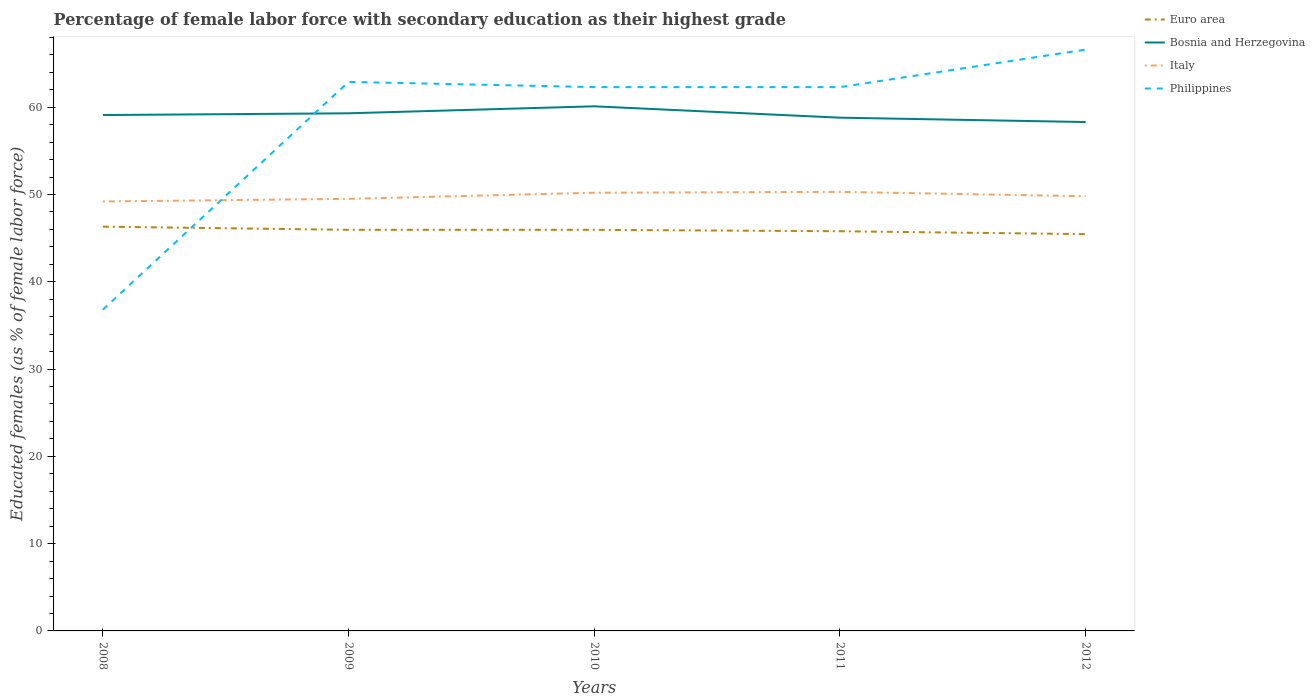How many different coloured lines are there?
Keep it short and to the point. 4. Across all years, what is the maximum percentage of female labor force with secondary education in Italy?
Provide a short and direct response. 49.2. What is the difference between the highest and the second highest percentage of female labor force with secondary education in Bosnia and Herzegovina?
Offer a terse response. 1.8. Is the percentage of female labor force with secondary education in Italy strictly greater than the percentage of female labor force with secondary education in Euro area over the years?
Provide a succinct answer. No. How many lines are there?
Your response must be concise. 4. Are the values on the major ticks of Y-axis written in scientific E-notation?
Provide a short and direct response. No. Does the graph contain any zero values?
Give a very brief answer. No. Where does the legend appear in the graph?
Provide a succinct answer. Top right. What is the title of the graph?
Give a very brief answer. Percentage of female labor force with secondary education as their highest grade. What is the label or title of the Y-axis?
Your answer should be compact. Educated females (as % of female labor force). What is the Educated females (as % of female labor force) in Euro area in 2008?
Your answer should be very brief. 46.31. What is the Educated females (as % of female labor force) in Bosnia and Herzegovina in 2008?
Make the answer very short. 59.1. What is the Educated females (as % of female labor force) of Italy in 2008?
Provide a short and direct response. 49.2. What is the Educated females (as % of female labor force) in Philippines in 2008?
Provide a short and direct response. 36.8. What is the Educated females (as % of female labor force) of Euro area in 2009?
Provide a succinct answer. 45.95. What is the Educated females (as % of female labor force) of Bosnia and Herzegovina in 2009?
Offer a very short reply. 59.3. What is the Educated females (as % of female labor force) of Italy in 2009?
Provide a short and direct response. 49.5. What is the Educated females (as % of female labor force) in Philippines in 2009?
Offer a very short reply. 62.9. What is the Educated females (as % of female labor force) of Euro area in 2010?
Your answer should be compact. 45.95. What is the Educated females (as % of female labor force) in Bosnia and Herzegovina in 2010?
Offer a very short reply. 60.1. What is the Educated females (as % of female labor force) of Italy in 2010?
Ensure brevity in your answer.  50.2. What is the Educated females (as % of female labor force) in Philippines in 2010?
Your answer should be compact. 62.3. What is the Educated females (as % of female labor force) of Euro area in 2011?
Give a very brief answer. 45.79. What is the Educated females (as % of female labor force) of Bosnia and Herzegovina in 2011?
Ensure brevity in your answer.  58.8. What is the Educated females (as % of female labor force) in Italy in 2011?
Your answer should be compact. 50.3. What is the Educated females (as % of female labor force) of Philippines in 2011?
Provide a succinct answer. 62.3. What is the Educated females (as % of female labor force) in Euro area in 2012?
Keep it short and to the point. 45.46. What is the Educated females (as % of female labor force) of Bosnia and Herzegovina in 2012?
Make the answer very short. 58.3. What is the Educated females (as % of female labor force) in Italy in 2012?
Keep it short and to the point. 49.8. What is the Educated females (as % of female labor force) in Philippines in 2012?
Make the answer very short. 66.6. Across all years, what is the maximum Educated females (as % of female labor force) in Euro area?
Provide a short and direct response. 46.31. Across all years, what is the maximum Educated females (as % of female labor force) of Bosnia and Herzegovina?
Provide a short and direct response. 60.1. Across all years, what is the maximum Educated females (as % of female labor force) in Italy?
Your response must be concise. 50.3. Across all years, what is the maximum Educated females (as % of female labor force) of Philippines?
Offer a terse response. 66.6. Across all years, what is the minimum Educated females (as % of female labor force) in Euro area?
Make the answer very short. 45.46. Across all years, what is the minimum Educated females (as % of female labor force) of Bosnia and Herzegovina?
Give a very brief answer. 58.3. Across all years, what is the minimum Educated females (as % of female labor force) of Italy?
Give a very brief answer. 49.2. Across all years, what is the minimum Educated females (as % of female labor force) in Philippines?
Keep it short and to the point. 36.8. What is the total Educated females (as % of female labor force) of Euro area in the graph?
Offer a terse response. 229.46. What is the total Educated females (as % of female labor force) of Bosnia and Herzegovina in the graph?
Your response must be concise. 295.6. What is the total Educated females (as % of female labor force) in Italy in the graph?
Keep it short and to the point. 249. What is the total Educated females (as % of female labor force) in Philippines in the graph?
Keep it short and to the point. 290.9. What is the difference between the Educated females (as % of female labor force) of Euro area in 2008 and that in 2009?
Ensure brevity in your answer.  0.36. What is the difference between the Educated females (as % of female labor force) of Italy in 2008 and that in 2009?
Make the answer very short. -0.3. What is the difference between the Educated females (as % of female labor force) of Philippines in 2008 and that in 2009?
Your answer should be compact. -26.1. What is the difference between the Educated females (as % of female labor force) of Euro area in 2008 and that in 2010?
Your answer should be compact. 0.36. What is the difference between the Educated females (as % of female labor force) of Philippines in 2008 and that in 2010?
Your answer should be very brief. -25.5. What is the difference between the Educated females (as % of female labor force) of Euro area in 2008 and that in 2011?
Make the answer very short. 0.52. What is the difference between the Educated females (as % of female labor force) in Italy in 2008 and that in 2011?
Give a very brief answer. -1.1. What is the difference between the Educated females (as % of female labor force) of Philippines in 2008 and that in 2011?
Give a very brief answer. -25.5. What is the difference between the Educated females (as % of female labor force) in Euro area in 2008 and that in 2012?
Your response must be concise. 0.86. What is the difference between the Educated females (as % of female labor force) of Philippines in 2008 and that in 2012?
Keep it short and to the point. -29.8. What is the difference between the Educated females (as % of female labor force) of Euro area in 2009 and that in 2010?
Your answer should be compact. 0. What is the difference between the Educated females (as % of female labor force) in Philippines in 2009 and that in 2010?
Give a very brief answer. 0.6. What is the difference between the Educated females (as % of female labor force) in Euro area in 2009 and that in 2011?
Offer a terse response. 0.16. What is the difference between the Educated females (as % of female labor force) of Bosnia and Herzegovina in 2009 and that in 2011?
Provide a short and direct response. 0.5. What is the difference between the Educated females (as % of female labor force) in Italy in 2009 and that in 2011?
Provide a short and direct response. -0.8. What is the difference between the Educated females (as % of female labor force) in Philippines in 2009 and that in 2011?
Provide a succinct answer. 0.6. What is the difference between the Educated females (as % of female labor force) of Euro area in 2009 and that in 2012?
Make the answer very short. 0.5. What is the difference between the Educated females (as % of female labor force) in Italy in 2009 and that in 2012?
Ensure brevity in your answer.  -0.3. What is the difference between the Educated females (as % of female labor force) of Philippines in 2009 and that in 2012?
Your response must be concise. -3.7. What is the difference between the Educated females (as % of female labor force) in Euro area in 2010 and that in 2011?
Your response must be concise. 0.16. What is the difference between the Educated females (as % of female labor force) of Bosnia and Herzegovina in 2010 and that in 2011?
Your response must be concise. 1.3. What is the difference between the Educated females (as % of female labor force) of Italy in 2010 and that in 2011?
Your answer should be very brief. -0.1. What is the difference between the Educated females (as % of female labor force) in Euro area in 2010 and that in 2012?
Your answer should be compact. 0.49. What is the difference between the Educated females (as % of female labor force) of Italy in 2010 and that in 2012?
Provide a succinct answer. 0.4. What is the difference between the Educated females (as % of female labor force) of Philippines in 2010 and that in 2012?
Offer a very short reply. -4.3. What is the difference between the Educated females (as % of female labor force) in Euro area in 2011 and that in 2012?
Your response must be concise. 0.33. What is the difference between the Educated females (as % of female labor force) in Euro area in 2008 and the Educated females (as % of female labor force) in Bosnia and Herzegovina in 2009?
Your response must be concise. -12.99. What is the difference between the Educated females (as % of female labor force) in Euro area in 2008 and the Educated females (as % of female labor force) in Italy in 2009?
Your response must be concise. -3.19. What is the difference between the Educated females (as % of female labor force) in Euro area in 2008 and the Educated females (as % of female labor force) in Philippines in 2009?
Your answer should be very brief. -16.59. What is the difference between the Educated females (as % of female labor force) in Bosnia and Herzegovina in 2008 and the Educated females (as % of female labor force) in Italy in 2009?
Your answer should be compact. 9.6. What is the difference between the Educated females (as % of female labor force) in Bosnia and Herzegovina in 2008 and the Educated females (as % of female labor force) in Philippines in 2009?
Your response must be concise. -3.8. What is the difference between the Educated females (as % of female labor force) of Italy in 2008 and the Educated females (as % of female labor force) of Philippines in 2009?
Provide a short and direct response. -13.7. What is the difference between the Educated females (as % of female labor force) of Euro area in 2008 and the Educated females (as % of female labor force) of Bosnia and Herzegovina in 2010?
Ensure brevity in your answer.  -13.79. What is the difference between the Educated females (as % of female labor force) of Euro area in 2008 and the Educated females (as % of female labor force) of Italy in 2010?
Keep it short and to the point. -3.89. What is the difference between the Educated females (as % of female labor force) of Euro area in 2008 and the Educated females (as % of female labor force) of Philippines in 2010?
Your answer should be compact. -15.99. What is the difference between the Educated females (as % of female labor force) in Bosnia and Herzegovina in 2008 and the Educated females (as % of female labor force) in Italy in 2010?
Keep it short and to the point. 8.9. What is the difference between the Educated females (as % of female labor force) of Euro area in 2008 and the Educated females (as % of female labor force) of Bosnia and Herzegovina in 2011?
Provide a short and direct response. -12.49. What is the difference between the Educated females (as % of female labor force) in Euro area in 2008 and the Educated females (as % of female labor force) in Italy in 2011?
Make the answer very short. -3.99. What is the difference between the Educated females (as % of female labor force) of Euro area in 2008 and the Educated females (as % of female labor force) of Philippines in 2011?
Offer a very short reply. -15.99. What is the difference between the Educated females (as % of female labor force) in Bosnia and Herzegovina in 2008 and the Educated females (as % of female labor force) in Italy in 2011?
Provide a succinct answer. 8.8. What is the difference between the Educated females (as % of female labor force) of Bosnia and Herzegovina in 2008 and the Educated females (as % of female labor force) of Philippines in 2011?
Your response must be concise. -3.2. What is the difference between the Educated females (as % of female labor force) of Italy in 2008 and the Educated females (as % of female labor force) of Philippines in 2011?
Provide a succinct answer. -13.1. What is the difference between the Educated females (as % of female labor force) of Euro area in 2008 and the Educated females (as % of female labor force) of Bosnia and Herzegovina in 2012?
Provide a short and direct response. -11.99. What is the difference between the Educated females (as % of female labor force) in Euro area in 2008 and the Educated females (as % of female labor force) in Italy in 2012?
Your answer should be very brief. -3.49. What is the difference between the Educated females (as % of female labor force) in Euro area in 2008 and the Educated females (as % of female labor force) in Philippines in 2012?
Your response must be concise. -20.29. What is the difference between the Educated females (as % of female labor force) of Bosnia and Herzegovina in 2008 and the Educated females (as % of female labor force) of Italy in 2012?
Provide a short and direct response. 9.3. What is the difference between the Educated females (as % of female labor force) of Italy in 2008 and the Educated females (as % of female labor force) of Philippines in 2012?
Give a very brief answer. -17.4. What is the difference between the Educated females (as % of female labor force) of Euro area in 2009 and the Educated females (as % of female labor force) of Bosnia and Herzegovina in 2010?
Provide a short and direct response. -14.15. What is the difference between the Educated females (as % of female labor force) of Euro area in 2009 and the Educated females (as % of female labor force) of Italy in 2010?
Give a very brief answer. -4.25. What is the difference between the Educated females (as % of female labor force) in Euro area in 2009 and the Educated females (as % of female labor force) in Philippines in 2010?
Your answer should be compact. -16.35. What is the difference between the Educated females (as % of female labor force) in Bosnia and Herzegovina in 2009 and the Educated females (as % of female labor force) in Philippines in 2010?
Your response must be concise. -3. What is the difference between the Educated females (as % of female labor force) of Euro area in 2009 and the Educated females (as % of female labor force) of Bosnia and Herzegovina in 2011?
Offer a terse response. -12.85. What is the difference between the Educated females (as % of female labor force) of Euro area in 2009 and the Educated females (as % of female labor force) of Italy in 2011?
Make the answer very short. -4.35. What is the difference between the Educated females (as % of female labor force) in Euro area in 2009 and the Educated females (as % of female labor force) in Philippines in 2011?
Make the answer very short. -16.35. What is the difference between the Educated females (as % of female labor force) in Bosnia and Herzegovina in 2009 and the Educated females (as % of female labor force) in Philippines in 2011?
Make the answer very short. -3. What is the difference between the Educated females (as % of female labor force) in Euro area in 2009 and the Educated females (as % of female labor force) in Bosnia and Herzegovina in 2012?
Keep it short and to the point. -12.35. What is the difference between the Educated females (as % of female labor force) in Euro area in 2009 and the Educated females (as % of female labor force) in Italy in 2012?
Your response must be concise. -3.85. What is the difference between the Educated females (as % of female labor force) in Euro area in 2009 and the Educated females (as % of female labor force) in Philippines in 2012?
Provide a succinct answer. -20.65. What is the difference between the Educated females (as % of female labor force) in Bosnia and Herzegovina in 2009 and the Educated females (as % of female labor force) in Italy in 2012?
Offer a terse response. 9.5. What is the difference between the Educated females (as % of female labor force) of Bosnia and Herzegovina in 2009 and the Educated females (as % of female labor force) of Philippines in 2012?
Your answer should be very brief. -7.3. What is the difference between the Educated females (as % of female labor force) in Italy in 2009 and the Educated females (as % of female labor force) in Philippines in 2012?
Give a very brief answer. -17.1. What is the difference between the Educated females (as % of female labor force) in Euro area in 2010 and the Educated females (as % of female labor force) in Bosnia and Herzegovina in 2011?
Keep it short and to the point. -12.85. What is the difference between the Educated females (as % of female labor force) of Euro area in 2010 and the Educated females (as % of female labor force) of Italy in 2011?
Your answer should be very brief. -4.35. What is the difference between the Educated females (as % of female labor force) in Euro area in 2010 and the Educated females (as % of female labor force) in Philippines in 2011?
Your answer should be compact. -16.35. What is the difference between the Educated females (as % of female labor force) of Bosnia and Herzegovina in 2010 and the Educated females (as % of female labor force) of Philippines in 2011?
Keep it short and to the point. -2.2. What is the difference between the Educated females (as % of female labor force) in Italy in 2010 and the Educated females (as % of female labor force) in Philippines in 2011?
Offer a very short reply. -12.1. What is the difference between the Educated females (as % of female labor force) in Euro area in 2010 and the Educated females (as % of female labor force) in Bosnia and Herzegovina in 2012?
Give a very brief answer. -12.35. What is the difference between the Educated females (as % of female labor force) of Euro area in 2010 and the Educated females (as % of female labor force) of Italy in 2012?
Ensure brevity in your answer.  -3.85. What is the difference between the Educated females (as % of female labor force) of Euro area in 2010 and the Educated females (as % of female labor force) of Philippines in 2012?
Give a very brief answer. -20.65. What is the difference between the Educated females (as % of female labor force) in Bosnia and Herzegovina in 2010 and the Educated females (as % of female labor force) in Philippines in 2012?
Give a very brief answer. -6.5. What is the difference between the Educated females (as % of female labor force) in Italy in 2010 and the Educated females (as % of female labor force) in Philippines in 2012?
Your answer should be compact. -16.4. What is the difference between the Educated females (as % of female labor force) of Euro area in 2011 and the Educated females (as % of female labor force) of Bosnia and Herzegovina in 2012?
Your answer should be compact. -12.51. What is the difference between the Educated females (as % of female labor force) of Euro area in 2011 and the Educated females (as % of female labor force) of Italy in 2012?
Provide a short and direct response. -4.01. What is the difference between the Educated females (as % of female labor force) of Euro area in 2011 and the Educated females (as % of female labor force) of Philippines in 2012?
Keep it short and to the point. -20.81. What is the difference between the Educated females (as % of female labor force) in Bosnia and Herzegovina in 2011 and the Educated females (as % of female labor force) in Italy in 2012?
Your answer should be very brief. 9. What is the difference between the Educated females (as % of female labor force) of Italy in 2011 and the Educated females (as % of female labor force) of Philippines in 2012?
Your response must be concise. -16.3. What is the average Educated females (as % of female labor force) in Euro area per year?
Your answer should be compact. 45.89. What is the average Educated females (as % of female labor force) of Bosnia and Herzegovina per year?
Your answer should be very brief. 59.12. What is the average Educated females (as % of female labor force) of Italy per year?
Make the answer very short. 49.8. What is the average Educated females (as % of female labor force) of Philippines per year?
Provide a short and direct response. 58.18. In the year 2008, what is the difference between the Educated females (as % of female labor force) of Euro area and Educated females (as % of female labor force) of Bosnia and Herzegovina?
Ensure brevity in your answer.  -12.79. In the year 2008, what is the difference between the Educated females (as % of female labor force) of Euro area and Educated females (as % of female labor force) of Italy?
Your response must be concise. -2.89. In the year 2008, what is the difference between the Educated females (as % of female labor force) of Euro area and Educated females (as % of female labor force) of Philippines?
Your answer should be compact. 9.51. In the year 2008, what is the difference between the Educated females (as % of female labor force) in Bosnia and Herzegovina and Educated females (as % of female labor force) in Philippines?
Your answer should be very brief. 22.3. In the year 2009, what is the difference between the Educated females (as % of female labor force) of Euro area and Educated females (as % of female labor force) of Bosnia and Herzegovina?
Give a very brief answer. -13.35. In the year 2009, what is the difference between the Educated females (as % of female labor force) of Euro area and Educated females (as % of female labor force) of Italy?
Your answer should be very brief. -3.55. In the year 2009, what is the difference between the Educated females (as % of female labor force) of Euro area and Educated females (as % of female labor force) of Philippines?
Provide a succinct answer. -16.95. In the year 2010, what is the difference between the Educated females (as % of female labor force) of Euro area and Educated females (as % of female labor force) of Bosnia and Herzegovina?
Ensure brevity in your answer.  -14.15. In the year 2010, what is the difference between the Educated females (as % of female labor force) in Euro area and Educated females (as % of female labor force) in Italy?
Offer a very short reply. -4.25. In the year 2010, what is the difference between the Educated females (as % of female labor force) in Euro area and Educated females (as % of female labor force) in Philippines?
Your answer should be very brief. -16.35. In the year 2010, what is the difference between the Educated females (as % of female labor force) in Bosnia and Herzegovina and Educated females (as % of female labor force) in Italy?
Provide a succinct answer. 9.9. In the year 2011, what is the difference between the Educated females (as % of female labor force) of Euro area and Educated females (as % of female labor force) of Bosnia and Herzegovina?
Ensure brevity in your answer.  -13.01. In the year 2011, what is the difference between the Educated females (as % of female labor force) of Euro area and Educated females (as % of female labor force) of Italy?
Ensure brevity in your answer.  -4.51. In the year 2011, what is the difference between the Educated females (as % of female labor force) of Euro area and Educated females (as % of female labor force) of Philippines?
Make the answer very short. -16.51. In the year 2011, what is the difference between the Educated females (as % of female labor force) in Bosnia and Herzegovina and Educated females (as % of female labor force) in Philippines?
Make the answer very short. -3.5. In the year 2012, what is the difference between the Educated females (as % of female labor force) in Euro area and Educated females (as % of female labor force) in Bosnia and Herzegovina?
Provide a succinct answer. -12.84. In the year 2012, what is the difference between the Educated females (as % of female labor force) in Euro area and Educated females (as % of female labor force) in Italy?
Provide a succinct answer. -4.34. In the year 2012, what is the difference between the Educated females (as % of female labor force) in Euro area and Educated females (as % of female labor force) in Philippines?
Make the answer very short. -21.14. In the year 2012, what is the difference between the Educated females (as % of female labor force) in Italy and Educated females (as % of female labor force) in Philippines?
Your answer should be compact. -16.8. What is the ratio of the Educated females (as % of female labor force) in Euro area in 2008 to that in 2009?
Offer a terse response. 1.01. What is the ratio of the Educated females (as % of female labor force) in Bosnia and Herzegovina in 2008 to that in 2009?
Your response must be concise. 1. What is the ratio of the Educated females (as % of female labor force) of Philippines in 2008 to that in 2009?
Keep it short and to the point. 0.59. What is the ratio of the Educated females (as % of female labor force) of Euro area in 2008 to that in 2010?
Offer a very short reply. 1.01. What is the ratio of the Educated females (as % of female labor force) in Bosnia and Herzegovina in 2008 to that in 2010?
Offer a terse response. 0.98. What is the ratio of the Educated females (as % of female labor force) of Italy in 2008 to that in 2010?
Your answer should be very brief. 0.98. What is the ratio of the Educated females (as % of female labor force) in Philippines in 2008 to that in 2010?
Give a very brief answer. 0.59. What is the ratio of the Educated females (as % of female labor force) of Euro area in 2008 to that in 2011?
Make the answer very short. 1.01. What is the ratio of the Educated females (as % of female labor force) of Bosnia and Herzegovina in 2008 to that in 2011?
Your answer should be very brief. 1.01. What is the ratio of the Educated females (as % of female labor force) of Italy in 2008 to that in 2011?
Your response must be concise. 0.98. What is the ratio of the Educated females (as % of female labor force) of Philippines in 2008 to that in 2011?
Your answer should be very brief. 0.59. What is the ratio of the Educated females (as % of female labor force) of Euro area in 2008 to that in 2012?
Your response must be concise. 1.02. What is the ratio of the Educated females (as % of female labor force) of Bosnia and Herzegovina in 2008 to that in 2012?
Your answer should be very brief. 1.01. What is the ratio of the Educated females (as % of female labor force) of Italy in 2008 to that in 2012?
Provide a succinct answer. 0.99. What is the ratio of the Educated females (as % of female labor force) in Philippines in 2008 to that in 2012?
Provide a succinct answer. 0.55. What is the ratio of the Educated females (as % of female labor force) of Euro area in 2009 to that in 2010?
Give a very brief answer. 1. What is the ratio of the Educated females (as % of female labor force) in Bosnia and Herzegovina in 2009 to that in 2010?
Your response must be concise. 0.99. What is the ratio of the Educated females (as % of female labor force) of Italy in 2009 to that in 2010?
Ensure brevity in your answer.  0.99. What is the ratio of the Educated females (as % of female labor force) in Philippines in 2009 to that in 2010?
Make the answer very short. 1.01. What is the ratio of the Educated females (as % of female labor force) of Bosnia and Herzegovina in 2009 to that in 2011?
Provide a succinct answer. 1.01. What is the ratio of the Educated females (as % of female labor force) in Italy in 2009 to that in 2011?
Offer a very short reply. 0.98. What is the ratio of the Educated females (as % of female labor force) in Philippines in 2009 to that in 2011?
Your answer should be very brief. 1.01. What is the ratio of the Educated females (as % of female labor force) of Euro area in 2009 to that in 2012?
Your answer should be compact. 1.01. What is the ratio of the Educated females (as % of female labor force) in Bosnia and Herzegovina in 2009 to that in 2012?
Your answer should be compact. 1.02. What is the ratio of the Educated females (as % of female labor force) of Philippines in 2009 to that in 2012?
Make the answer very short. 0.94. What is the ratio of the Educated females (as % of female labor force) in Euro area in 2010 to that in 2011?
Your response must be concise. 1. What is the ratio of the Educated females (as % of female labor force) in Bosnia and Herzegovina in 2010 to that in 2011?
Offer a terse response. 1.02. What is the ratio of the Educated females (as % of female labor force) in Philippines in 2010 to that in 2011?
Your answer should be very brief. 1. What is the ratio of the Educated females (as % of female labor force) in Euro area in 2010 to that in 2012?
Offer a terse response. 1.01. What is the ratio of the Educated females (as % of female labor force) of Bosnia and Herzegovina in 2010 to that in 2012?
Provide a short and direct response. 1.03. What is the ratio of the Educated females (as % of female labor force) of Philippines in 2010 to that in 2012?
Keep it short and to the point. 0.94. What is the ratio of the Educated females (as % of female labor force) of Euro area in 2011 to that in 2012?
Provide a succinct answer. 1.01. What is the ratio of the Educated females (as % of female labor force) of Bosnia and Herzegovina in 2011 to that in 2012?
Offer a terse response. 1.01. What is the ratio of the Educated females (as % of female labor force) of Philippines in 2011 to that in 2012?
Provide a short and direct response. 0.94. What is the difference between the highest and the second highest Educated females (as % of female labor force) in Euro area?
Ensure brevity in your answer.  0.36. What is the difference between the highest and the second highest Educated females (as % of female labor force) in Italy?
Ensure brevity in your answer.  0.1. What is the difference between the highest and the lowest Educated females (as % of female labor force) of Euro area?
Provide a short and direct response. 0.86. What is the difference between the highest and the lowest Educated females (as % of female labor force) of Philippines?
Offer a terse response. 29.8. 